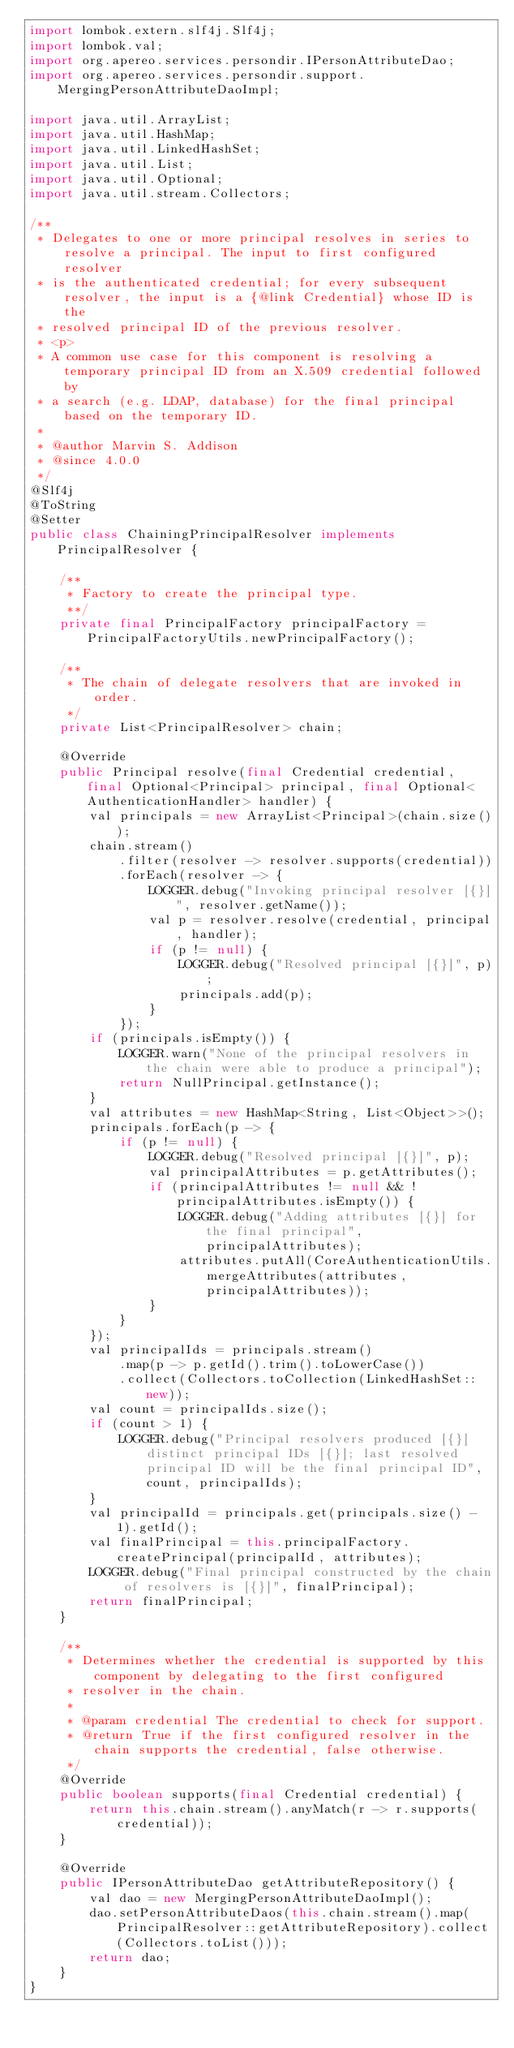<code> <loc_0><loc_0><loc_500><loc_500><_Java_>import lombok.extern.slf4j.Slf4j;
import lombok.val;
import org.apereo.services.persondir.IPersonAttributeDao;
import org.apereo.services.persondir.support.MergingPersonAttributeDaoImpl;

import java.util.ArrayList;
import java.util.HashMap;
import java.util.LinkedHashSet;
import java.util.List;
import java.util.Optional;
import java.util.stream.Collectors;

/**
 * Delegates to one or more principal resolves in series to resolve a principal. The input to first configured resolver
 * is the authenticated credential; for every subsequent resolver, the input is a {@link Credential} whose ID is the
 * resolved principal ID of the previous resolver.
 * <p>
 * A common use case for this component is resolving a temporary principal ID from an X.509 credential followed by
 * a search (e.g. LDAP, database) for the final principal based on the temporary ID.
 *
 * @author Marvin S. Addison
 * @since 4.0.0
 */
@Slf4j
@ToString
@Setter
public class ChainingPrincipalResolver implements PrincipalResolver {

    /**
     * Factory to create the principal type.
     **/
    private final PrincipalFactory principalFactory = PrincipalFactoryUtils.newPrincipalFactory();

    /**
     * The chain of delegate resolvers that are invoked in order.
     */
    private List<PrincipalResolver> chain;

    @Override
    public Principal resolve(final Credential credential, final Optional<Principal> principal, final Optional<AuthenticationHandler> handler) {
        val principals = new ArrayList<Principal>(chain.size());
        chain.stream()
            .filter(resolver -> resolver.supports(credential))
            .forEach(resolver -> {
                LOGGER.debug("Invoking principal resolver [{}]", resolver.getName());
                val p = resolver.resolve(credential, principal, handler);
                if (p != null) {
                    LOGGER.debug("Resolved principal [{}]", p);
                    principals.add(p);
                }
            });
        if (principals.isEmpty()) {
            LOGGER.warn("None of the principal resolvers in the chain were able to produce a principal");
            return NullPrincipal.getInstance();
        }
        val attributes = new HashMap<String, List<Object>>();
        principals.forEach(p -> {
            if (p != null) {
                LOGGER.debug("Resolved principal [{}]", p);
                val principalAttributes = p.getAttributes();
                if (principalAttributes != null && !principalAttributes.isEmpty()) {
                    LOGGER.debug("Adding attributes [{}] for the final principal", principalAttributes);
                    attributes.putAll(CoreAuthenticationUtils.mergeAttributes(attributes, principalAttributes));
                }
            }
        });
        val principalIds = principals.stream()
            .map(p -> p.getId().trim().toLowerCase())
            .collect(Collectors.toCollection(LinkedHashSet::new));
        val count = principalIds.size();
        if (count > 1) {
            LOGGER.debug("Principal resolvers produced [{}] distinct principal IDs [{}]; last resolved principal ID will be the final principal ID", count, principalIds);
        }
        val principalId = principals.get(principals.size() - 1).getId();
        val finalPrincipal = this.principalFactory.createPrincipal(principalId, attributes);
        LOGGER.debug("Final principal constructed by the chain of resolvers is [{}]", finalPrincipal);
        return finalPrincipal;
    }

    /**
     * Determines whether the credential is supported by this component by delegating to the first configured
     * resolver in the chain.
     *
     * @param credential The credential to check for support.
     * @return True if the first configured resolver in the chain supports the credential, false otherwise.
     */
    @Override
    public boolean supports(final Credential credential) {
        return this.chain.stream().anyMatch(r -> r.supports(credential));
    }

    @Override
    public IPersonAttributeDao getAttributeRepository() {
        val dao = new MergingPersonAttributeDaoImpl();
        dao.setPersonAttributeDaos(this.chain.stream().map(PrincipalResolver::getAttributeRepository).collect(Collectors.toList()));
        return dao;
    }
}
</code> 